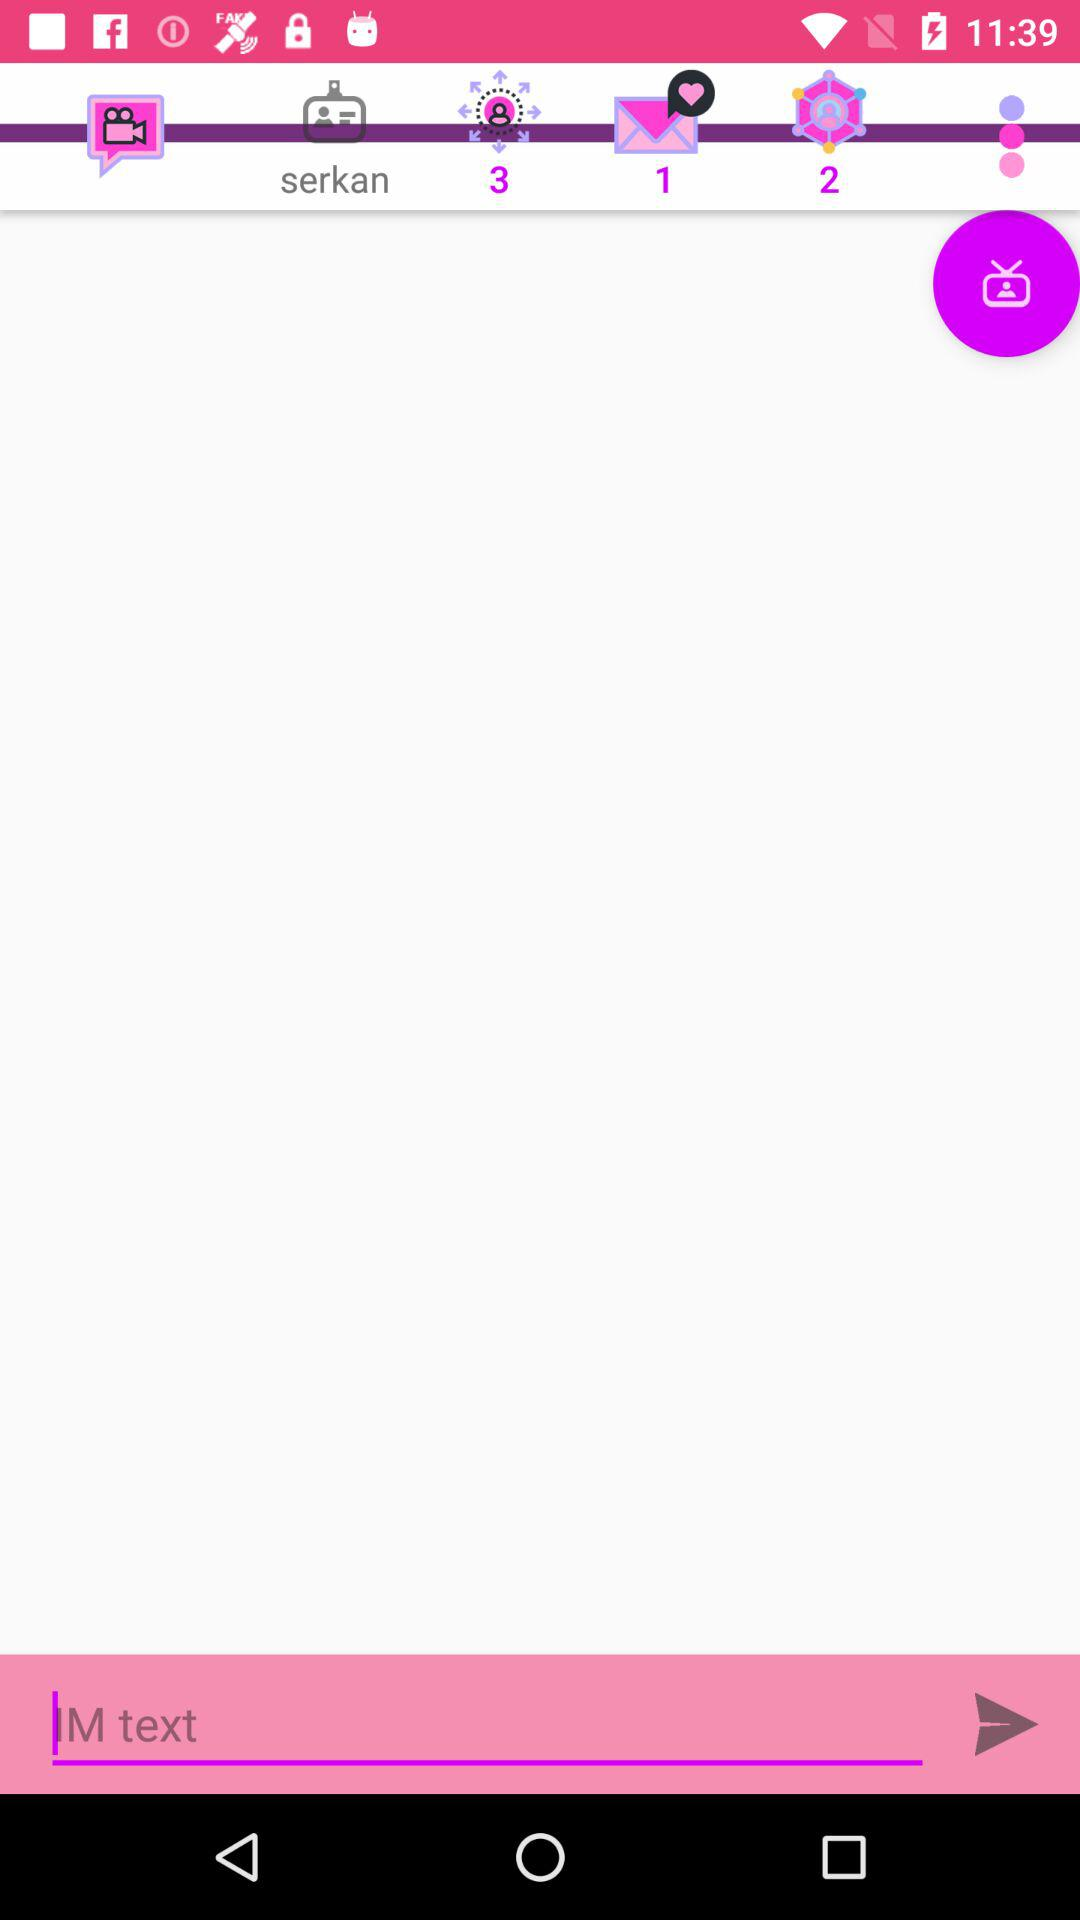What is the number of unread messages? There is 1 unread message. 